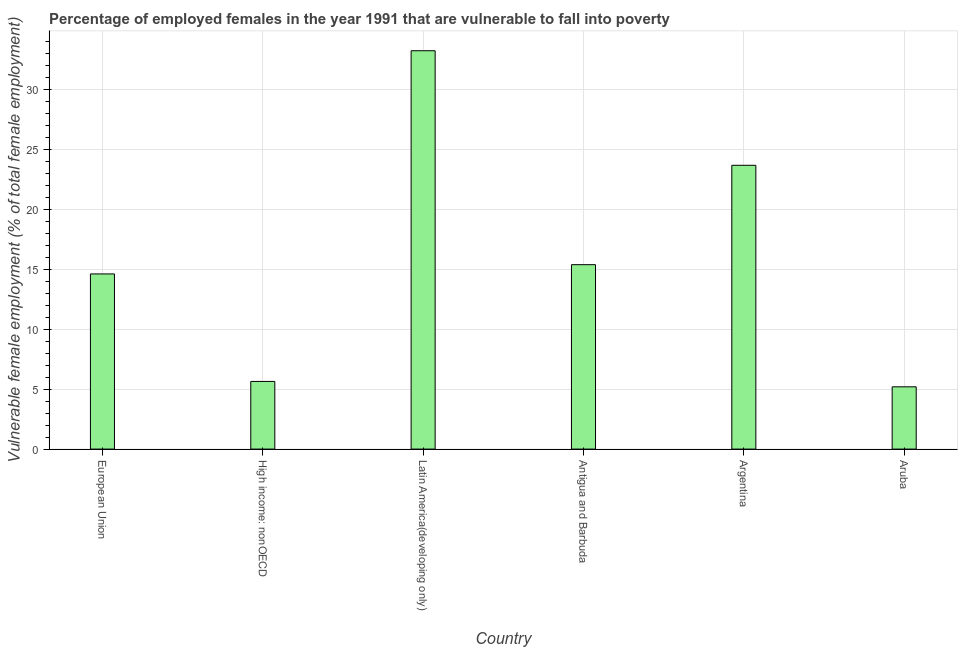Does the graph contain any zero values?
Your answer should be compact. No. Does the graph contain grids?
Give a very brief answer. Yes. What is the title of the graph?
Offer a terse response. Percentage of employed females in the year 1991 that are vulnerable to fall into poverty. What is the label or title of the X-axis?
Give a very brief answer. Country. What is the label or title of the Y-axis?
Offer a terse response. Vulnerable female employment (% of total female employment). What is the percentage of employed females who are vulnerable to fall into poverty in Latin America(developing only)?
Provide a short and direct response. 33.27. Across all countries, what is the maximum percentage of employed females who are vulnerable to fall into poverty?
Give a very brief answer. 33.27. Across all countries, what is the minimum percentage of employed females who are vulnerable to fall into poverty?
Offer a terse response. 5.2. In which country was the percentage of employed females who are vulnerable to fall into poverty maximum?
Give a very brief answer. Latin America(developing only). In which country was the percentage of employed females who are vulnerable to fall into poverty minimum?
Offer a very short reply. Aruba. What is the sum of the percentage of employed females who are vulnerable to fall into poverty?
Keep it short and to the point. 97.84. What is the difference between the percentage of employed females who are vulnerable to fall into poverty in Argentina and Aruba?
Ensure brevity in your answer.  18.5. What is the average percentage of employed females who are vulnerable to fall into poverty per country?
Your answer should be very brief. 16.31. What is the median percentage of employed females who are vulnerable to fall into poverty?
Give a very brief answer. 15.01. What is the ratio of the percentage of employed females who are vulnerable to fall into poverty in Argentina to that in Aruba?
Your answer should be compact. 4.56. Is the percentage of employed females who are vulnerable to fall into poverty in European Union less than that in Latin America(developing only)?
Provide a short and direct response. Yes. What is the difference between the highest and the second highest percentage of employed females who are vulnerable to fall into poverty?
Offer a very short reply. 9.56. What is the difference between the highest and the lowest percentage of employed females who are vulnerable to fall into poverty?
Give a very brief answer. 28.07. Are all the bars in the graph horizontal?
Your answer should be very brief. No. Are the values on the major ticks of Y-axis written in scientific E-notation?
Offer a very short reply. No. What is the Vulnerable female employment (% of total female employment) of European Union?
Ensure brevity in your answer.  14.63. What is the Vulnerable female employment (% of total female employment) of High income: nonOECD?
Ensure brevity in your answer.  5.65. What is the Vulnerable female employment (% of total female employment) in Latin America(developing only)?
Give a very brief answer. 33.27. What is the Vulnerable female employment (% of total female employment) in Antigua and Barbuda?
Ensure brevity in your answer.  15.4. What is the Vulnerable female employment (% of total female employment) of Argentina?
Your answer should be very brief. 23.7. What is the Vulnerable female employment (% of total female employment) of Aruba?
Ensure brevity in your answer.  5.2. What is the difference between the Vulnerable female employment (% of total female employment) in European Union and High income: nonOECD?
Keep it short and to the point. 8.98. What is the difference between the Vulnerable female employment (% of total female employment) in European Union and Latin America(developing only)?
Offer a terse response. -18.64. What is the difference between the Vulnerable female employment (% of total female employment) in European Union and Antigua and Barbuda?
Keep it short and to the point. -0.77. What is the difference between the Vulnerable female employment (% of total female employment) in European Union and Argentina?
Offer a terse response. -9.07. What is the difference between the Vulnerable female employment (% of total female employment) in European Union and Aruba?
Provide a succinct answer. 9.43. What is the difference between the Vulnerable female employment (% of total female employment) in High income: nonOECD and Latin America(developing only)?
Provide a short and direct response. -27.62. What is the difference between the Vulnerable female employment (% of total female employment) in High income: nonOECD and Antigua and Barbuda?
Provide a succinct answer. -9.75. What is the difference between the Vulnerable female employment (% of total female employment) in High income: nonOECD and Argentina?
Make the answer very short. -18.05. What is the difference between the Vulnerable female employment (% of total female employment) in High income: nonOECD and Aruba?
Offer a terse response. 0.45. What is the difference between the Vulnerable female employment (% of total female employment) in Latin America(developing only) and Antigua and Barbuda?
Offer a terse response. 17.87. What is the difference between the Vulnerable female employment (% of total female employment) in Latin America(developing only) and Argentina?
Give a very brief answer. 9.57. What is the difference between the Vulnerable female employment (% of total female employment) in Latin America(developing only) and Aruba?
Provide a short and direct response. 28.07. What is the ratio of the Vulnerable female employment (% of total female employment) in European Union to that in High income: nonOECD?
Provide a succinct answer. 2.59. What is the ratio of the Vulnerable female employment (% of total female employment) in European Union to that in Latin America(developing only)?
Your response must be concise. 0.44. What is the ratio of the Vulnerable female employment (% of total female employment) in European Union to that in Antigua and Barbuda?
Provide a succinct answer. 0.95. What is the ratio of the Vulnerable female employment (% of total female employment) in European Union to that in Argentina?
Make the answer very short. 0.62. What is the ratio of the Vulnerable female employment (% of total female employment) in European Union to that in Aruba?
Provide a short and direct response. 2.81. What is the ratio of the Vulnerable female employment (% of total female employment) in High income: nonOECD to that in Latin America(developing only)?
Your answer should be very brief. 0.17. What is the ratio of the Vulnerable female employment (% of total female employment) in High income: nonOECD to that in Antigua and Barbuda?
Make the answer very short. 0.37. What is the ratio of the Vulnerable female employment (% of total female employment) in High income: nonOECD to that in Argentina?
Keep it short and to the point. 0.24. What is the ratio of the Vulnerable female employment (% of total female employment) in High income: nonOECD to that in Aruba?
Provide a succinct answer. 1.09. What is the ratio of the Vulnerable female employment (% of total female employment) in Latin America(developing only) to that in Antigua and Barbuda?
Give a very brief answer. 2.16. What is the ratio of the Vulnerable female employment (% of total female employment) in Latin America(developing only) to that in Argentina?
Your answer should be compact. 1.4. What is the ratio of the Vulnerable female employment (% of total female employment) in Latin America(developing only) to that in Aruba?
Offer a very short reply. 6.4. What is the ratio of the Vulnerable female employment (% of total female employment) in Antigua and Barbuda to that in Argentina?
Ensure brevity in your answer.  0.65. What is the ratio of the Vulnerable female employment (% of total female employment) in Antigua and Barbuda to that in Aruba?
Offer a very short reply. 2.96. What is the ratio of the Vulnerable female employment (% of total female employment) in Argentina to that in Aruba?
Offer a terse response. 4.56. 